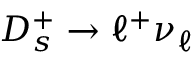<formula> <loc_0><loc_0><loc_500><loc_500>D _ { s } ^ { + } \to \ell ^ { + } \nu _ { \ell }</formula> 